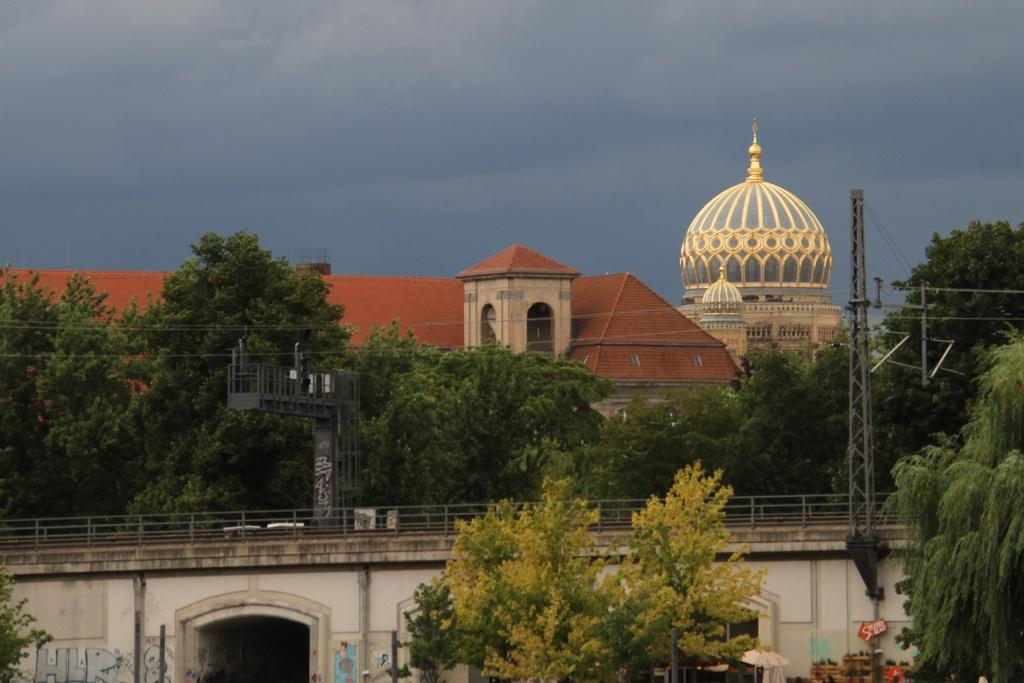What type of buildings can be seen in the image? There are castles in the image. What other natural elements are present in the image? There are trees in the image. Are there any man-made structures besides the castles? Yes, there are poles in the image. What is visible in the background of the image? The sky is visible in the image, and clouds are present in the sky. Can you tell me how many geese are flying over the castles in the image? There are no geese present in the image; it only features castles, trees, poles, and the sky. 